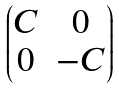<formula> <loc_0><loc_0><loc_500><loc_500>\begin{pmatrix} C & 0 \\ 0 & - C \end{pmatrix}</formula> 